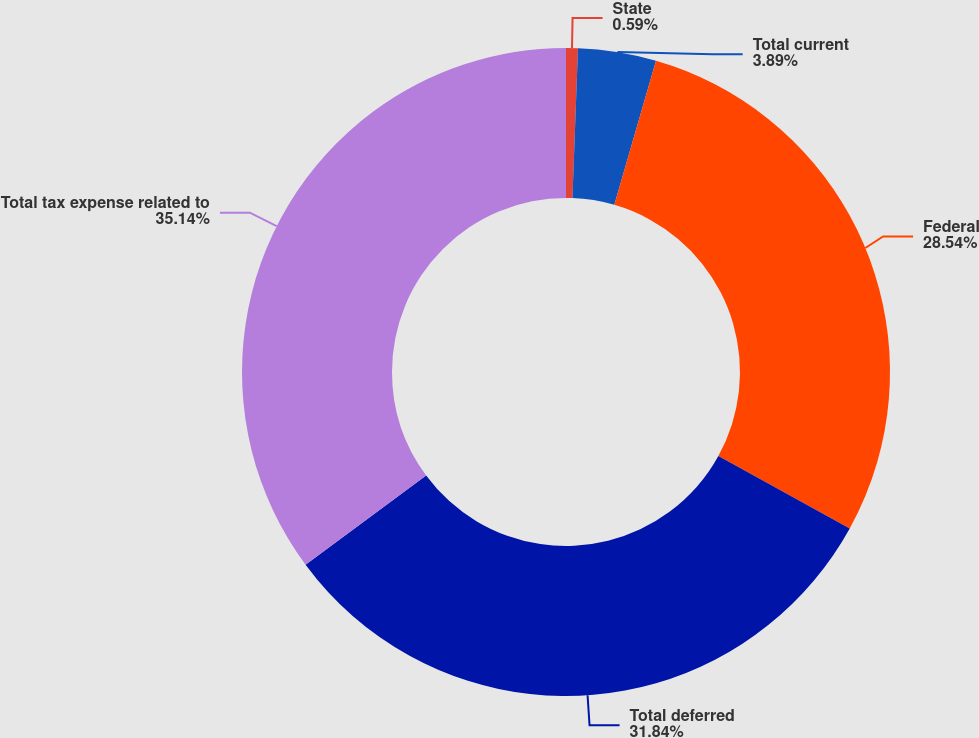<chart> <loc_0><loc_0><loc_500><loc_500><pie_chart><fcel>State<fcel>Total current<fcel>Federal<fcel>Total deferred<fcel>Total tax expense related to<nl><fcel>0.59%<fcel>3.89%<fcel>28.54%<fcel>31.84%<fcel>35.14%<nl></chart> 